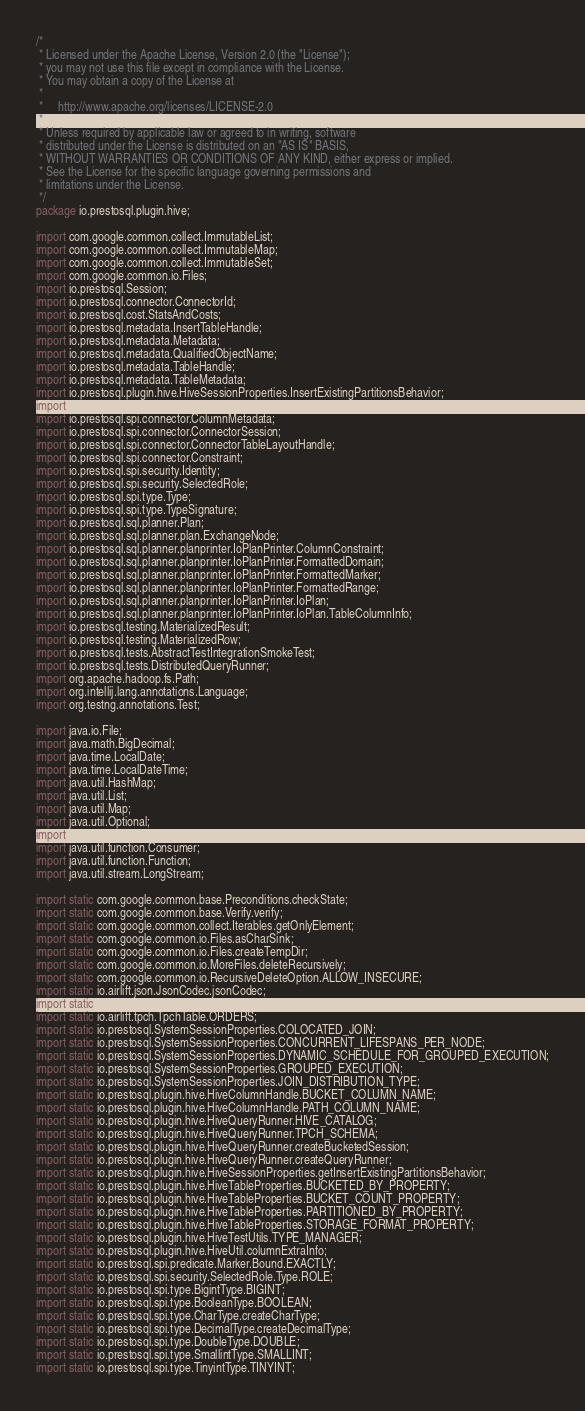Convert code to text. <code><loc_0><loc_0><loc_500><loc_500><_Java_>/*
 * Licensed under the Apache License, Version 2.0 (the "License");
 * you may not use this file except in compliance with the License.
 * You may obtain a copy of the License at
 *
 *     http://www.apache.org/licenses/LICENSE-2.0
 *
 * Unless required by applicable law or agreed to in writing, software
 * distributed under the License is distributed on an "AS IS" BASIS,
 * WITHOUT WARRANTIES OR CONDITIONS OF ANY KIND, either express or implied.
 * See the License for the specific language governing permissions and
 * limitations under the License.
 */
package io.prestosql.plugin.hive;

import com.google.common.collect.ImmutableList;
import com.google.common.collect.ImmutableMap;
import com.google.common.collect.ImmutableSet;
import com.google.common.io.Files;
import io.prestosql.Session;
import io.prestosql.connector.ConnectorId;
import io.prestosql.cost.StatsAndCosts;
import io.prestosql.metadata.InsertTableHandle;
import io.prestosql.metadata.Metadata;
import io.prestosql.metadata.QualifiedObjectName;
import io.prestosql.metadata.TableHandle;
import io.prestosql.metadata.TableMetadata;
import io.prestosql.plugin.hive.HiveSessionProperties.InsertExistingPartitionsBehavior;
import io.prestosql.spi.connector.CatalogSchemaTableName;
import io.prestosql.spi.connector.ColumnMetadata;
import io.prestosql.spi.connector.ConnectorSession;
import io.prestosql.spi.connector.ConnectorTableLayoutHandle;
import io.prestosql.spi.connector.Constraint;
import io.prestosql.spi.security.Identity;
import io.prestosql.spi.security.SelectedRole;
import io.prestosql.spi.type.Type;
import io.prestosql.spi.type.TypeSignature;
import io.prestosql.sql.planner.Plan;
import io.prestosql.sql.planner.plan.ExchangeNode;
import io.prestosql.sql.planner.planprinter.IoPlanPrinter.ColumnConstraint;
import io.prestosql.sql.planner.planprinter.IoPlanPrinter.FormattedDomain;
import io.prestosql.sql.planner.planprinter.IoPlanPrinter.FormattedMarker;
import io.prestosql.sql.planner.planprinter.IoPlanPrinter.FormattedRange;
import io.prestosql.sql.planner.planprinter.IoPlanPrinter.IoPlan;
import io.prestosql.sql.planner.planprinter.IoPlanPrinter.IoPlan.TableColumnInfo;
import io.prestosql.testing.MaterializedResult;
import io.prestosql.testing.MaterializedRow;
import io.prestosql.tests.AbstractTestIntegrationSmokeTest;
import io.prestosql.tests.DistributedQueryRunner;
import org.apache.hadoop.fs.Path;
import org.intellij.lang.annotations.Language;
import org.testng.annotations.Test;

import java.io.File;
import java.math.BigDecimal;
import java.time.LocalDate;
import java.time.LocalDateTime;
import java.util.HashMap;
import java.util.List;
import java.util.Map;
import java.util.Optional;
import java.util.function.BiConsumer;
import java.util.function.Consumer;
import java.util.function.Function;
import java.util.stream.LongStream;

import static com.google.common.base.Preconditions.checkState;
import static com.google.common.base.Verify.verify;
import static com.google.common.collect.Iterables.getOnlyElement;
import static com.google.common.io.Files.asCharSink;
import static com.google.common.io.Files.createTempDir;
import static com.google.common.io.MoreFiles.deleteRecursively;
import static com.google.common.io.RecursiveDeleteOption.ALLOW_INSECURE;
import static io.airlift.json.JsonCodec.jsonCodec;
import static io.airlift.tpch.TpchTable.CUSTOMER;
import static io.airlift.tpch.TpchTable.ORDERS;
import static io.prestosql.SystemSessionProperties.COLOCATED_JOIN;
import static io.prestosql.SystemSessionProperties.CONCURRENT_LIFESPANS_PER_NODE;
import static io.prestosql.SystemSessionProperties.DYNAMIC_SCHEDULE_FOR_GROUPED_EXECUTION;
import static io.prestosql.SystemSessionProperties.GROUPED_EXECUTION;
import static io.prestosql.SystemSessionProperties.JOIN_DISTRIBUTION_TYPE;
import static io.prestosql.plugin.hive.HiveColumnHandle.BUCKET_COLUMN_NAME;
import static io.prestosql.plugin.hive.HiveColumnHandle.PATH_COLUMN_NAME;
import static io.prestosql.plugin.hive.HiveQueryRunner.HIVE_CATALOG;
import static io.prestosql.plugin.hive.HiveQueryRunner.TPCH_SCHEMA;
import static io.prestosql.plugin.hive.HiveQueryRunner.createBucketedSession;
import static io.prestosql.plugin.hive.HiveQueryRunner.createQueryRunner;
import static io.prestosql.plugin.hive.HiveSessionProperties.getInsertExistingPartitionsBehavior;
import static io.prestosql.plugin.hive.HiveTableProperties.BUCKETED_BY_PROPERTY;
import static io.prestosql.plugin.hive.HiveTableProperties.BUCKET_COUNT_PROPERTY;
import static io.prestosql.plugin.hive.HiveTableProperties.PARTITIONED_BY_PROPERTY;
import static io.prestosql.plugin.hive.HiveTableProperties.STORAGE_FORMAT_PROPERTY;
import static io.prestosql.plugin.hive.HiveTestUtils.TYPE_MANAGER;
import static io.prestosql.plugin.hive.HiveUtil.columnExtraInfo;
import static io.prestosql.spi.predicate.Marker.Bound.EXACTLY;
import static io.prestosql.spi.security.SelectedRole.Type.ROLE;
import static io.prestosql.spi.type.BigintType.BIGINT;
import static io.prestosql.spi.type.BooleanType.BOOLEAN;
import static io.prestosql.spi.type.CharType.createCharType;
import static io.prestosql.spi.type.DecimalType.createDecimalType;
import static io.prestosql.spi.type.DoubleType.DOUBLE;
import static io.prestosql.spi.type.SmallintType.SMALLINT;
import static io.prestosql.spi.type.TinyintType.TINYINT;</code> 